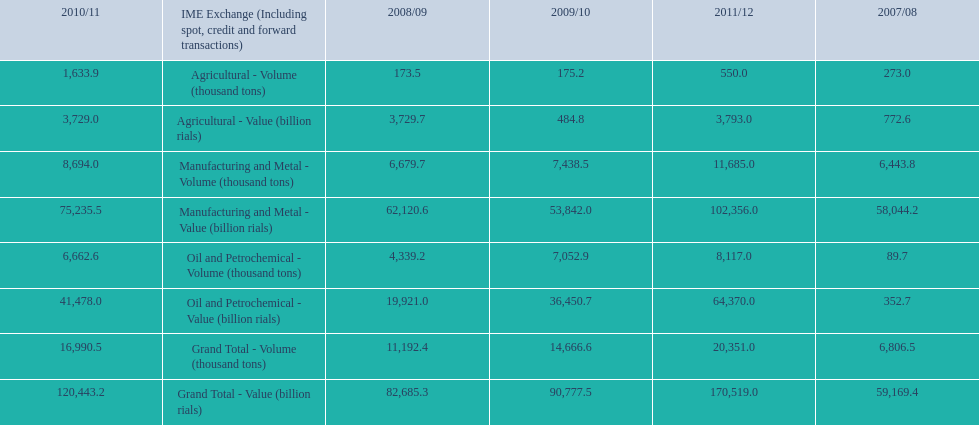What is the total agricultural value in 2008/09? 3,729.7. 